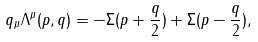<formula> <loc_0><loc_0><loc_500><loc_500>q _ { \mu } \Lambda ^ { \mu } ( p , q ) = - \Sigma ( p + \frac { q } { 2 } ) + \Sigma ( p - \frac { q } { 2 } ) ,</formula> 